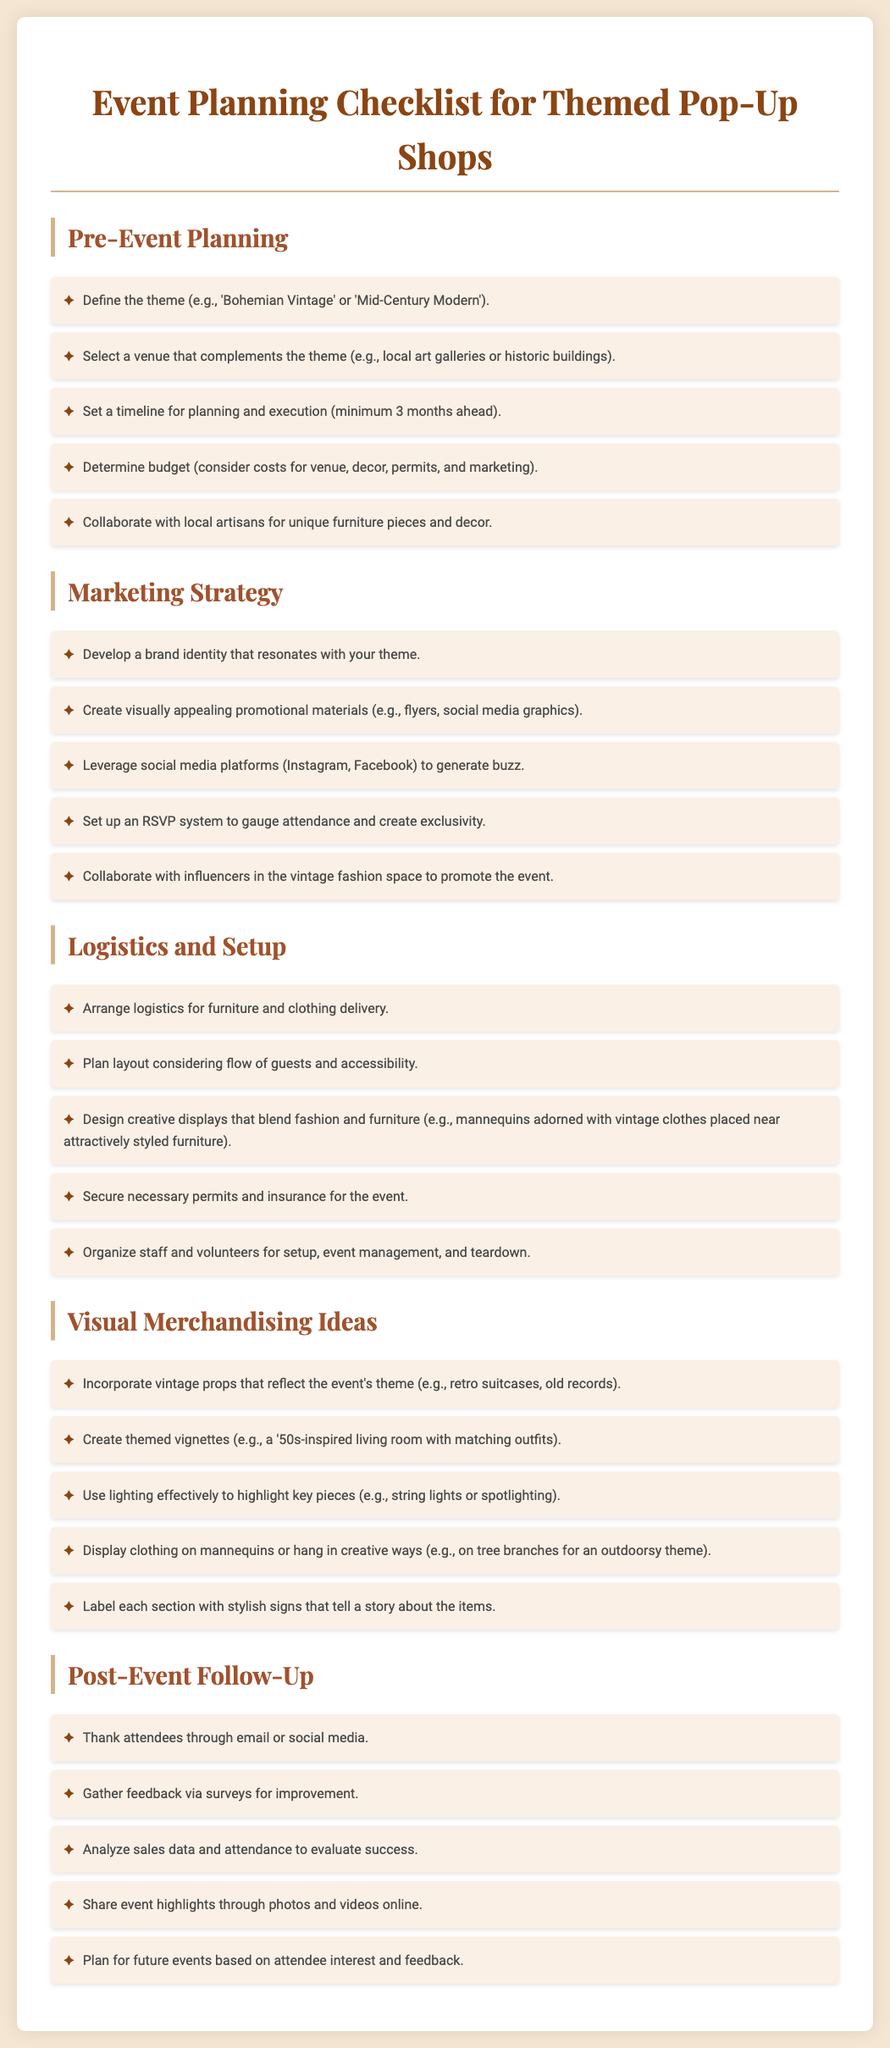What is the minimum timeline for planning the event? The document specifies a minimum timeline of 3 months for planning and execution.
Answer: 3 months What should be considered in the budget? The budget should consider costs for venue, decor, permits, and marketing.
Answer: Venue, decor, permits, marketing What type of venue is recommended? A venue that complements the theme, such as local art galleries or historic buildings, is recommended.
Answer: Local art galleries or historic buildings What should be included in the marketing strategy? The marketing strategy should include developing a brand identity, creating promotional materials, and leveraging social media.
Answer: Developing a brand identity, promotional materials, leveraging social media What is an example of a visual merchandising idea? The document suggests creating themed vignettes, such as a '50s-inspired living room with matching outfits.
Answer: Themed vignettes How can lighting be used effectively? Lighting can be used to highlight key pieces, such as string lights or spotlighting.
Answer: String lights or spotlighting What is a post-event follow-up action? A post-event follow-up action suggests gathering feedback via surveys.
Answer: Gathering feedback via surveys Which type of props should be incorporated into the displays? Incorporating vintage props that reflect the event's theme is advised.
Answer: Vintage props What is a reason for collaborating with local artisans? Collaborating with local artisans is suggested to obtain unique furniture pieces and decor.
Answer: Unique furniture pieces and decor 